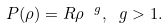Convert formula to latex. <formula><loc_0><loc_0><loc_500><loc_500>P ( \rho ) = R \rho ^ { \ g } , \ g > 1 .</formula> 